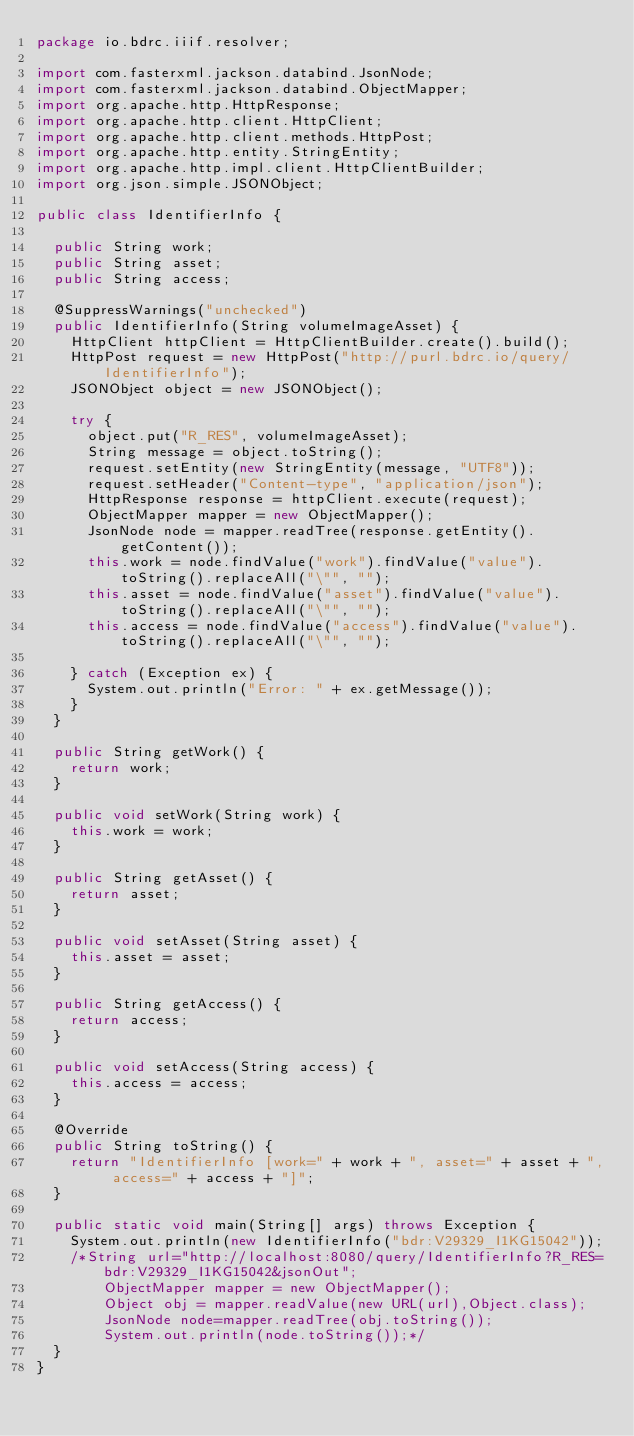<code> <loc_0><loc_0><loc_500><loc_500><_Java_>package io.bdrc.iiif.resolver;

import com.fasterxml.jackson.databind.JsonNode;
import com.fasterxml.jackson.databind.ObjectMapper;
import org.apache.http.HttpResponse;
import org.apache.http.client.HttpClient;
import org.apache.http.client.methods.HttpPost;
import org.apache.http.entity.StringEntity;
import org.apache.http.impl.client.HttpClientBuilder;
import org.json.simple.JSONObject;

public class IdentifierInfo {

  public String work;
  public String asset;
  public String access;

  @SuppressWarnings("unchecked")
  public IdentifierInfo(String volumeImageAsset) {
    HttpClient httpClient = HttpClientBuilder.create().build();
    HttpPost request = new HttpPost("http://purl.bdrc.io/query/IdentifierInfo");
    JSONObject object = new JSONObject();

    try {
      object.put("R_RES", volumeImageAsset);
      String message = object.toString();
      request.setEntity(new StringEntity(message, "UTF8"));
      request.setHeader("Content-type", "application/json");
      HttpResponse response = httpClient.execute(request);
      ObjectMapper mapper = new ObjectMapper();
      JsonNode node = mapper.readTree(response.getEntity().getContent());
      this.work = node.findValue("work").findValue("value").toString().replaceAll("\"", "");
      this.asset = node.findValue("asset").findValue("value").toString().replaceAll("\"", "");
      this.access = node.findValue("access").findValue("value").toString().replaceAll("\"", "");

    } catch (Exception ex) {
      System.out.println("Error: " + ex.getMessage());
    }
  }

  public String getWork() {
    return work;
  }

  public void setWork(String work) {
    this.work = work;
  }

  public String getAsset() {
    return asset;
  }

  public void setAsset(String asset) {
    this.asset = asset;
  }

  public String getAccess() {
    return access;
  }

  public void setAccess(String access) {
    this.access = access;
  }

  @Override
  public String toString() {
    return "IdentifierInfo [work=" + work + ", asset=" + asset + ", access=" + access + "]";
  }

  public static void main(String[] args) throws Exception {
    System.out.println(new IdentifierInfo("bdr:V29329_I1KG15042"));
    /*String url="http://localhost:8080/query/IdentifierInfo?R_RES=bdr:V29329_I1KG15042&jsonOut";
        ObjectMapper mapper = new ObjectMapper();
        Object obj = mapper.readValue(new URL(url),Object.class);
        JsonNode node=mapper.readTree(obj.toString());
        System.out.println(node.toString());*/
  }
}
</code> 